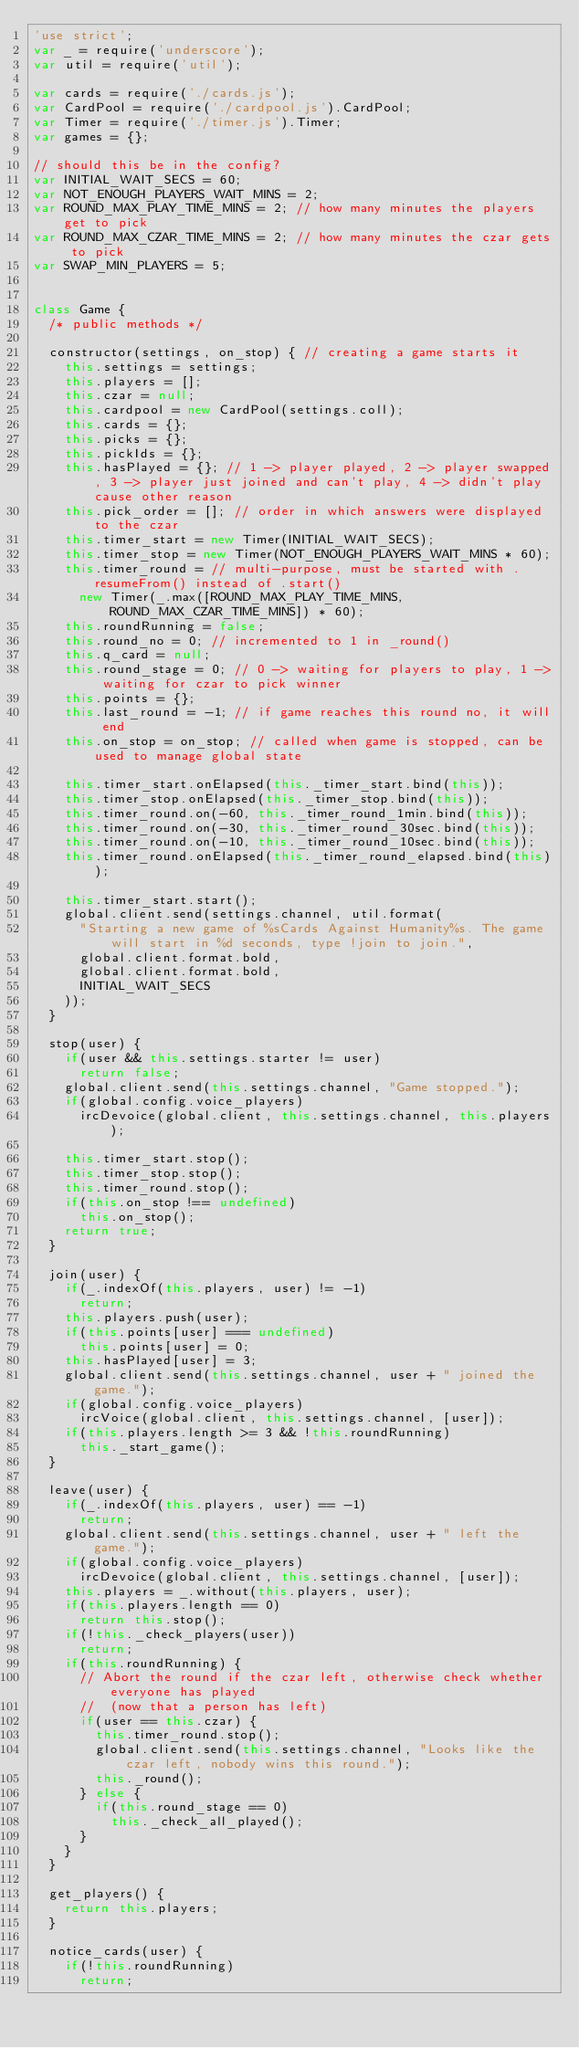<code> <loc_0><loc_0><loc_500><loc_500><_JavaScript_>'use strict';
var _ = require('underscore');
var util = require('util');

var cards = require('./cards.js');
var CardPool = require('./cardpool.js').CardPool;
var Timer = require('./timer.js').Timer;
var games = {};

// should this be in the config?
var INITIAL_WAIT_SECS = 60;
var NOT_ENOUGH_PLAYERS_WAIT_MINS = 2;
var ROUND_MAX_PLAY_TIME_MINS = 2; // how many minutes the players get to pick
var ROUND_MAX_CZAR_TIME_MINS = 2; // how many minutes the czar gets to pick
var SWAP_MIN_PLAYERS = 5;


class Game {
	/* public methods */

	constructor(settings, on_stop) { // creating a game starts it
		this.settings = settings;
		this.players = [];
		this.czar = null;
		this.cardpool = new CardPool(settings.coll);
		this.cards = {};
		this.picks = {};
		this.pickIds = {};
		this.hasPlayed = {}; // 1 -> player played, 2 -> player swapped, 3 -> player just joined and can't play, 4 -> didn't play cause other reason
		this.pick_order = []; // order in which answers were displayed to the czar
		this.timer_start = new Timer(INITIAL_WAIT_SECS);
		this.timer_stop = new Timer(NOT_ENOUGH_PLAYERS_WAIT_MINS * 60);
		this.timer_round = // multi-purpose, must be started with .resumeFrom() instead of .start()
			new Timer(_.max([ROUND_MAX_PLAY_TIME_MINS, ROUND_MAX_CZAR_TIME_MINS]) * 60);
		this.roundRunning = false;
		this.round_no = 0; // incremented to 1 in _round()
		this.q_card = null;
		this.round_stage = 0; // 0 -> waiting for players to play, 1 -> waiting for czar to pick winner
		this.points = {};
		this.last_round = -1; // if game reaches this round no, it will end
		this.on_stop = on_stop; // called when game is stopped, can be used to manage global state

		this.timer_start.onElapsed(this._timer_start.bind(this));
		this.timer_stop.onElapsed(this._timer_stop.bind(this));
		this.timer_round.on(-60, this._timer_round_1min.bind(this));
		this.timer_round.on(-30, this._timer_round_30sec.bind(this));
		this.timer_round.on(-10, this._timer_round_10sec.bind(this));
		this.timer_round.onElapsed(this._timer_round_elapsed.bind(this));

		this.timer_start.start();
		global.client.send(settings.channel, util.format(
			"Starting a new game of %sCards Against Humanity%s. The game will start in %d seconds, type !join to join.",
			global.client.format.bold,
			global.client.format.bold,
			INITIAL_WAIT_SECS
		));
	}

	stop(user) {
		if(user && this.settings.starter != user)
			return false;
		global.client.send(this.settings.channel, "Game stopped.");
		if(global.config.voice_players)
			ircDevoice(global.client, this.settings.channel, this.players);

		this.timer_start.stop();
		this.timer_stop.stop();
		this.timer_round.stop();
		if(this.on_stop !== undefined)
			this.on_stop();
		return true;
	}

	join(user) {
		if(_.indexOf(this.players, user) != -1)
			return;
		this.players.push(user);
		if(this.points[user] === undefined)
			this.points[user] = 0;
		this.hasPlayed[user] = 3;
		global.client.send(this.settings.channel, user + " joined the game.");
		if(global.config.voice_players)
			ircVoice(global.client, this.settings.channel, [user]);
		if(this.players.length >= 3 && !this.roundRunning)
			this._start_game();
	}

	leave(user) {
		if(_.indexOf(this.players, user) == -1)
			return;
		global.client.send(this.settings.channel, user + " left the game.");
		if(global.config.voice_players)
			ircDevoice(global.client, this.settings.channel, [user]);
		this.players = _.without(this.players, user);
		if(this.players.length == 0)
			return this.stop();
		if(!this._check_players(user))
			return;
		if(this.roundRunning) {
			// Abort the round if the czar left, otherwise check whether everyone has played
			//  (now that a person has left)
			if(user == this.czar) {
				this.timer_round.stop();
				global.client.send(this.settings.channel, "Looks like the czar left, nobody wins this round.");
				this._round();
			} else {
				if(this.round_stage == 0)
					this._check_all_played();
			}
		}
	}

	get_players() {
		return this.players;
	}

	notice_cards(user) {
		if(!this.roundRunning)
			return;</code> 